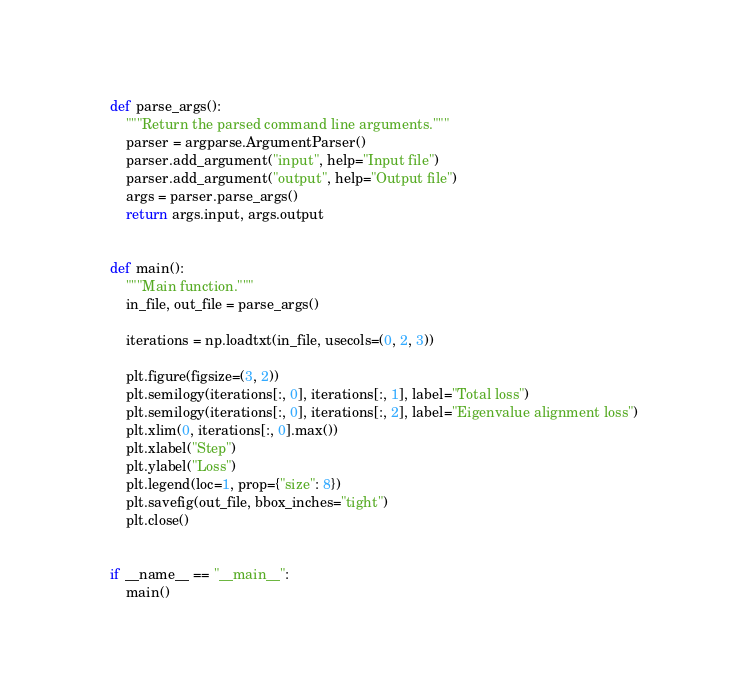Convert code to text. <code><loc_0><loc_0><loc_500><loc_500><_Python_>

def parse_args():
    """Return the parsed command line arguments."""
    parser = argparse.ArgumentParser()
    parser.add_argument("input", help="Input file")
    parser.add_argument("output", help="Output file")
    args = parser.parse_args()
    return args.input, args.output


def main():
    """Main function."""
    in_file, out_file = parse_args()

    iterations = np.loadtxt(in_file, usecols=(0, 2, 3))

    plt.figure(figsize=(3, 2))
    plt.semilogy(iterations[:, 0], iterations[:, 1], label="Total loss")
    plt.semilogy(iterations[:, 0], iterations[:, 2], label="Eigenvalue alignment loss")
    plt.xlim(0, iterations[:, 0].max())
    plt.xlabel("Step")
    plt.ylabel("Loss")
    plt.legend(loc=1, prop={"size": 8})
    plt.savefig(out_file, bbox_inches="tight")
    plt.close()


if __name__ == "__main__":
    main()
</code> 